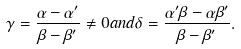<formula> <loc_0><loc_0><loc_500><loc_500>\gamma = \frac { \alpha - \alpha ^ { \prime } } { \beta - \beta ^ { \prime } } \neq 0 a n d \delta = \frac { \alpha ^ { \prime } \beta - \alpha \beta ^ { \prime } } { \beta - \beta ^ { \prime } } .</formula> 